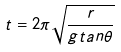Convert formula to latex. <formula><loc_0><loc_0><loc_500><loc_500>t = 2 \pi \sqrt { \frac { r } { g t a n \theta } }</formula> 